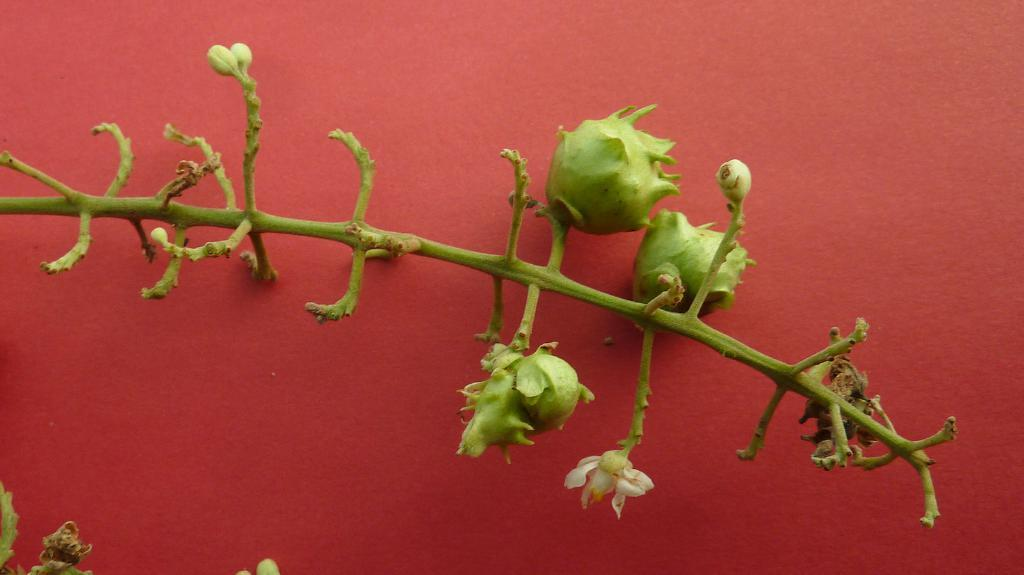What type of plant life can be seen in the image? There are buds and a flower in the image. Where are the buds and flower located? The buds and flower are on a branch. What is the branch attached to in the image? The branch is on an object. What type of machine is visible in the image? There is no machine present in the image; it features a branch with buds and a flower. What kind of meal is being prepared in the image? There is no meal preparation in the image; it focuses on plant life. 